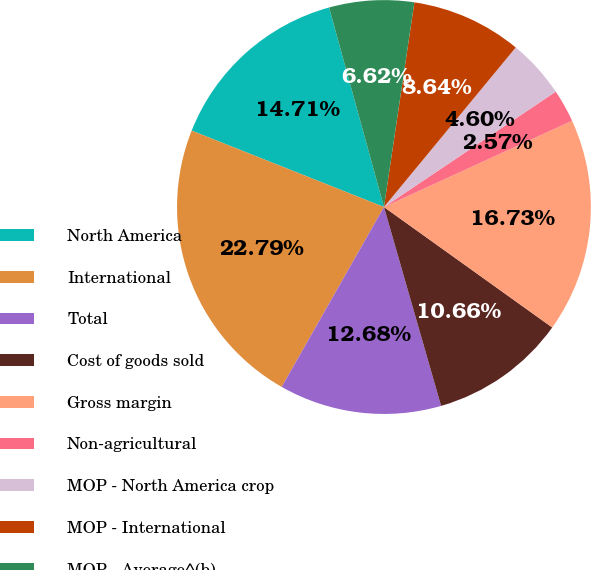<chart> <loc_0><loc_0><loc_500><loc_500><pie_chart><fcel>North America<fcel>International<fcel>Total<fcel>Cost of goods sold<fcel>Gross margin<fcel>Non-agricultural<fcel>MOP - North America crop<fcel>MOP - International<fcel>MOP - Average^(b)<nl><fcel>14.71%<fcel>22.79%<fcel>12.68%<fcel>10.66%<fcel>16.73%<fcel>2.57%<fcel>4.6%<fcel>8.64%<fcel>6.62%<nl></chart> 